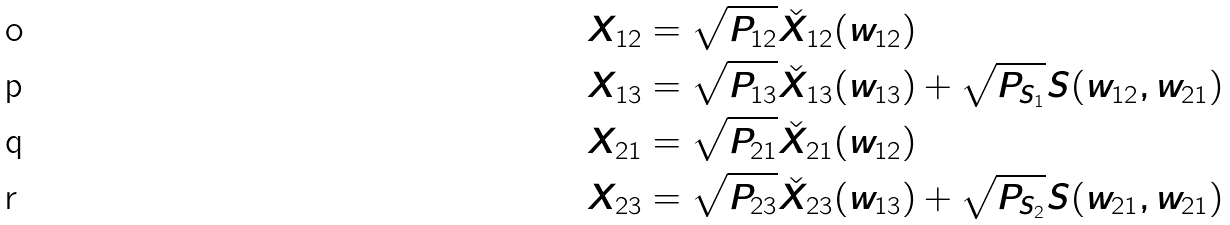Convert formula to latex. <formula><loc_0><loc_0><loc_500><loc_500>X _ { 1 2 } & = \sqrt { P _ { 1 2 } } \check { X } _ { 1 2 } ( w _ { 1 2 } ) \\ X _ { 1 3 } & = \sqrt { P _ { 1 3 } } \check { X } _ { 1 3 } ( w _ { 1 3 } ) + \sqrt { P _ { S _ { 1 } } } S ( w _ { 1 2 } , w _ { 2 1 } ) \\ X _ { 2 1 } & = \sqrt { P _ { 2 1 } } \check { X } _ { 2 1 } ( w _ { 1 2 } ) \\ X _ { 2 3 } & = \sqrt { P _ { 2 3 } } \check { X } _ { 2 3 } ( w _ { 1 3 } ) + \sqrt { P _ { S _ { 2 } } } S ( w _ { 2 1 } , w _ { 2 1 } )</formula> 